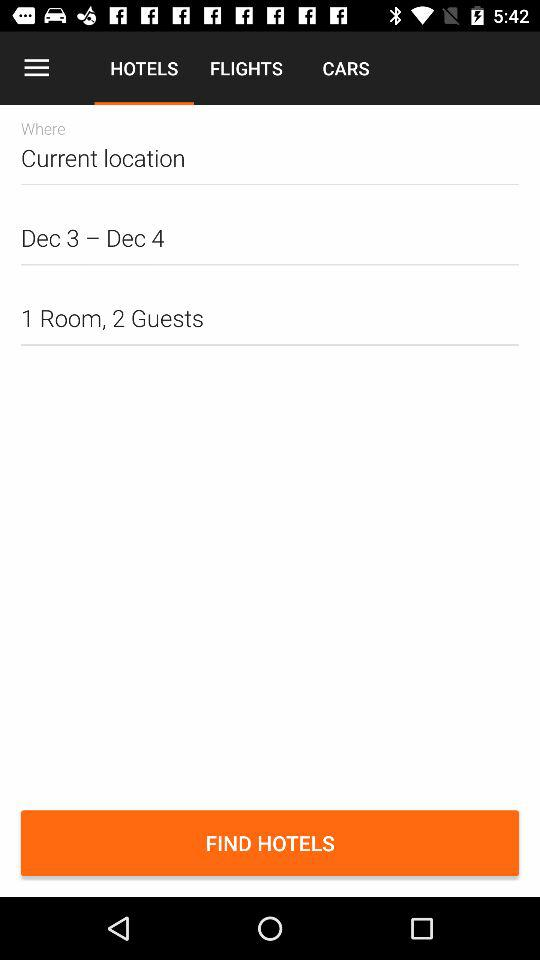How many rooms are selected? The selected room is 1. 